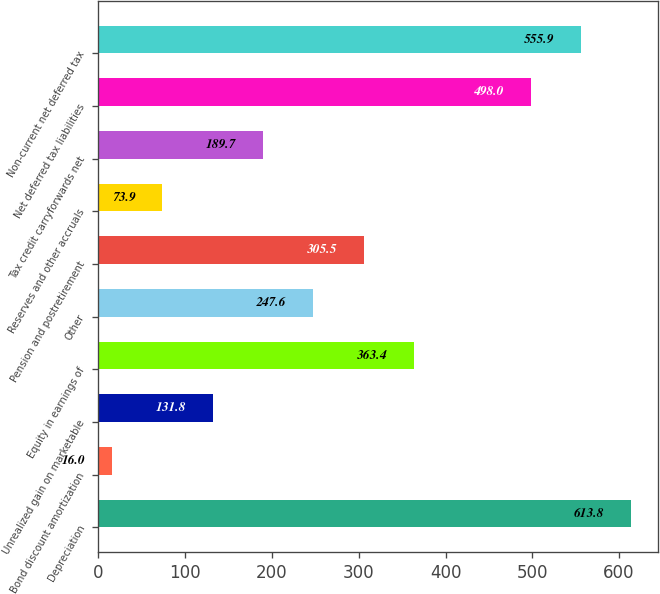Convert chart. <chart><loc_0><loc_0><loc_500><loc_500><bar_chart><fcel>Depreciation<fcel>Bond discount amortization<fcel>Unrealized gain on marketable<fcel>Equity in earnings of<fcel>Other<fcel>Pension and postretirement<fcel>Reserves and other accruals<fcel>Tax credit carryforwards net<fcel>Net deferred tax liabilities<fcel>Non-current net deferred tax<nl><fcel>613.8<fcel>16<fcel>131.8<fcel>363.4<fcel>247.6<fcel>305.5<fcel>73.9<fcel>189.7<fcel>498<fcel>555.9<nl></chart> 